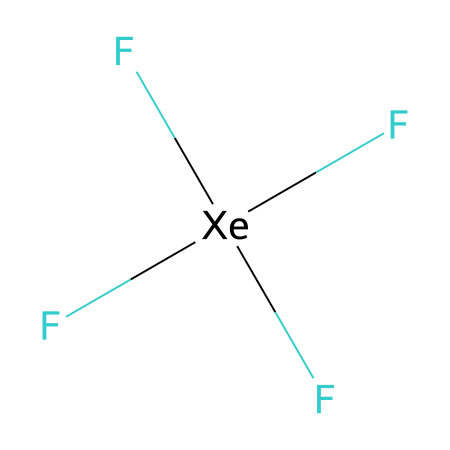How many fluorine atoms are present in xenon tetrafluoride? The SMILES representation shows four fluorine atoms bonded to the xenon atom, indicated by the four 'F' notations.
Answer: four What is the central atom in this compound? The structure indicates that xenon (Xe) is surrounded by the fluorine atoms, making it the central atom in this compound.
Answer: xenon How many bonds are formed between xenon and fluorine? Since there are four fluorine atoms attached to the central xenon atom, there are four single bonds formed between them.
Answer: four What is the hybridization of the central xenon atom in this compound? The xenon atom in xenon tetrafluoride is involved in four bonding pairs and has two lone pairs. This indicates an sp³d hybridization, typically associated with hypervalent compounds.
Answer: sp³d Why is xenon tetrafluoride considered a hypervalent compound? Hypervalent compounds are defined by having a central atom that can have more than eight electrons in its valence shell. In this case, xenon is bonded to four fluorine atoms, contributing to a total of 12 electrons around xenon.
Answer: yes 